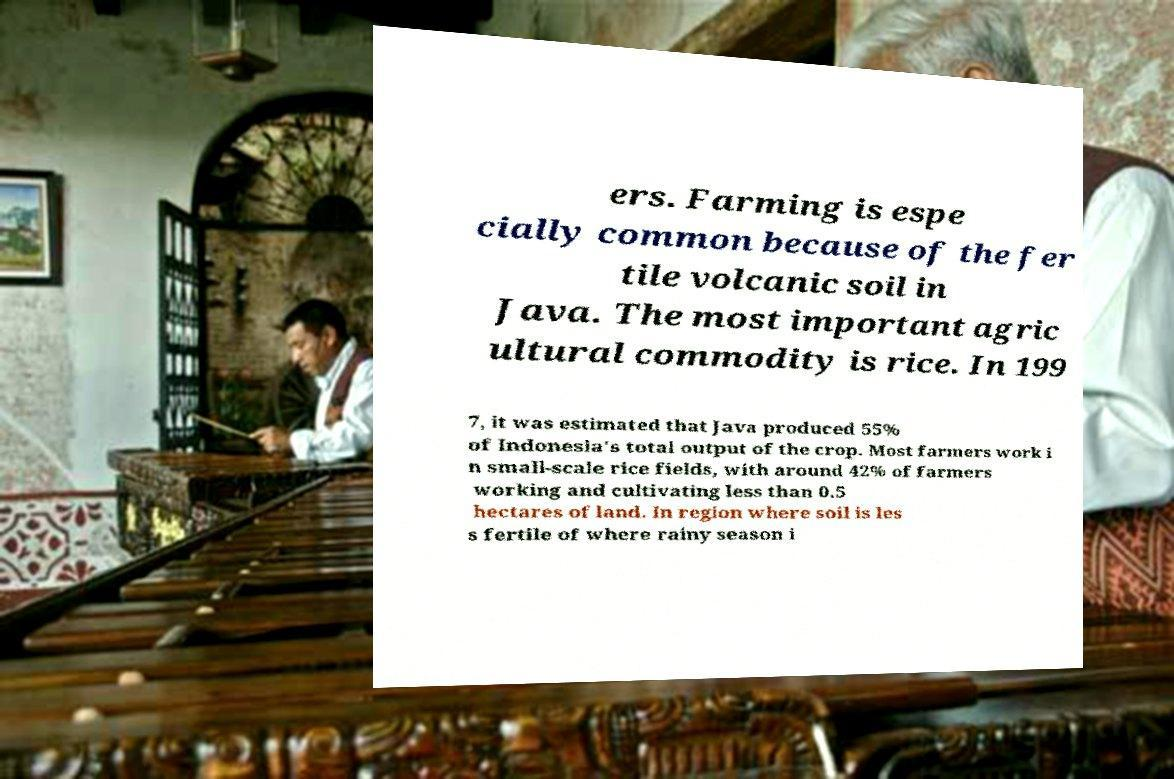Could you extract and type out the text from this image? ers. Farming is espe cially common because of the fer tile volcanic soil in Java. The most important agric ultural commodity is rice. In 199 7, it was estimated that Java produced 55% of Indonesia's total output of the crop. Most farmers work i n small-scale rice fields, with around 42% of farmers working and cultivating less than 0.5 hectares of land. In region where soil is les s fertile of where rainy season i 